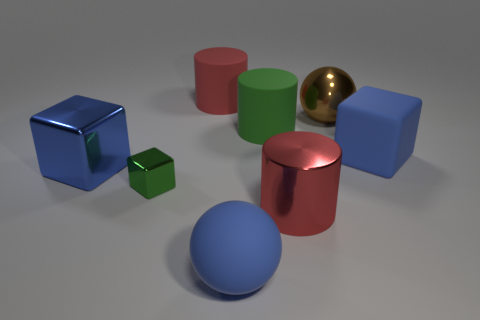Does the matte cylinder that is on the right side of the matte ball have the same color as the tiny thing that is in front of the big blue metal block?
Your answer should be compact. Yes. Are there any other things that have the same color as the small shiny object?
Provide a succinct answer. Yes. There is a large metallic object that is left of the large sphere that is in front of the large brown metal object; what color is it?
Offer a terse response. Blue. Are there any metal things?
Your answer should be very brief. Yes. There is a metal thing that is both on the left side of the red rubber thing and to the right of the big blue metallic cube; what is its color?
Give a very brief answer. Green. Is the size of the green cube that is behind the big shiny cylinder the same as the red cylinder in front of the big blue shiny thing?
Give a very brief answer. No. What number of other things are there of the same size as the blue ball?
Provide a succinct answer. 6. How many large brown shiny balls are on the left side of the large sphere to the left of the shiny sphere?
Keep it short and to the point. 0. Are there fewer matte spheres to the left of the blue matte ball than cyan cubes?
Offer a terse response. No. What shape is the red object in front of the big shiny object that is behind the matte thing that is on the right side of the large green rubber object?
Your answer should be very brief. Cylinder. 